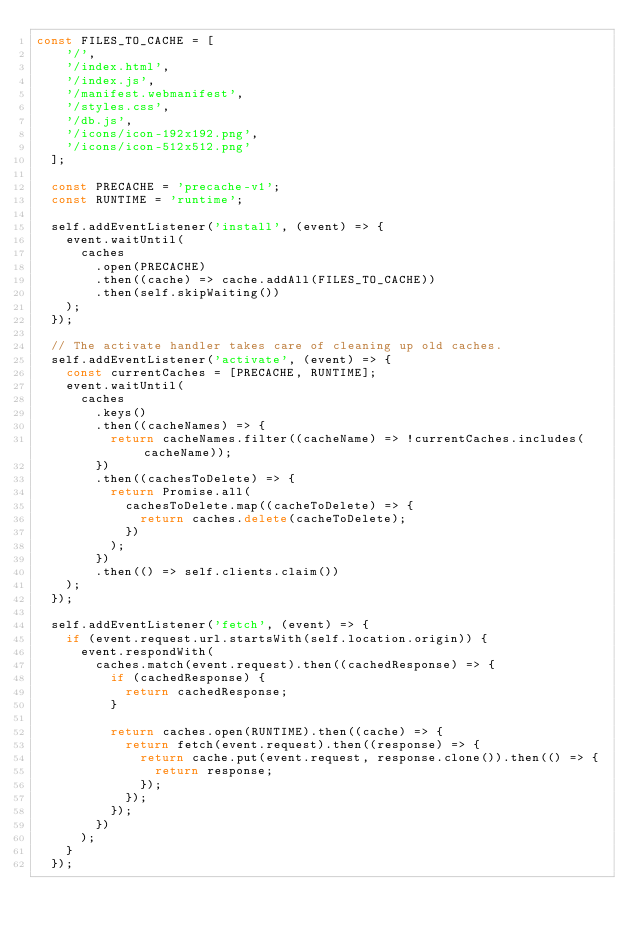<code> <loc_0><loc_0><loc_500><loc_500><_JavaScript_>const FILES_TO_CACHE = [
    '/',
    '/index.html',
    '/index.js',
    '/manifest.webmanifest',
    '/styles.css',
    '/db.js',
    '/icons/icon-192x192.png',
    '/icons/icon-512x512.png'
  ];
  
  const PRECACHE = 'precache-v1';
  const RUNTIME = 'runtime';
  
  self.addEventListener('install', (event) => {
    event.waitUntil(
      caches
        .open(PRECACHE)
        .then((cache) => cache.addAll(FILES_TO_CACHE))
        .then(self.skipWaiting())
    );
  });
  
  // The activate handler takes care of cleaning up old caches.
  self.addEventListener('activate', (event) => {
    const currentCaches = [PRECACHE, RUNTIME];
    event.waitUntil(
      caches
        .keys()
        .then((cacheNames) => {
          return cacheNames.filter((cacheName) => !currentCaches.includes(cacheName));
        })
        .then((cachesToDelete) => {
          return Promise.all(
            cachesToDelete.map((cacheToDelete) => {
              return caches.delete(cacheToDelete);
            })
          );
        })
        .then(() => self.clients.claim())
    );
  });
  
  self.addEventListener('fetch', (event) => {
    if (event.request.url.startsWith(self.location.origin)) {
      event.respondWith(
        caches.match(event.request).then((cachedResponse) => {
          if (cachedResponse) {
            return cachedResponse;
          }
  
          return caches.open(RUNTIME).then((cache) => {
            return fetch(event.request).then((response) => {
              return cache.put(event.request, response.clone()).then(() => {
                return response;
              });
            });
          });
        })
      );
    }
  });
  </code> 